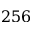Convert formula to latex. <formula><loc_0><loc_0><loc_500><loc_500>2 5 6</formula> 